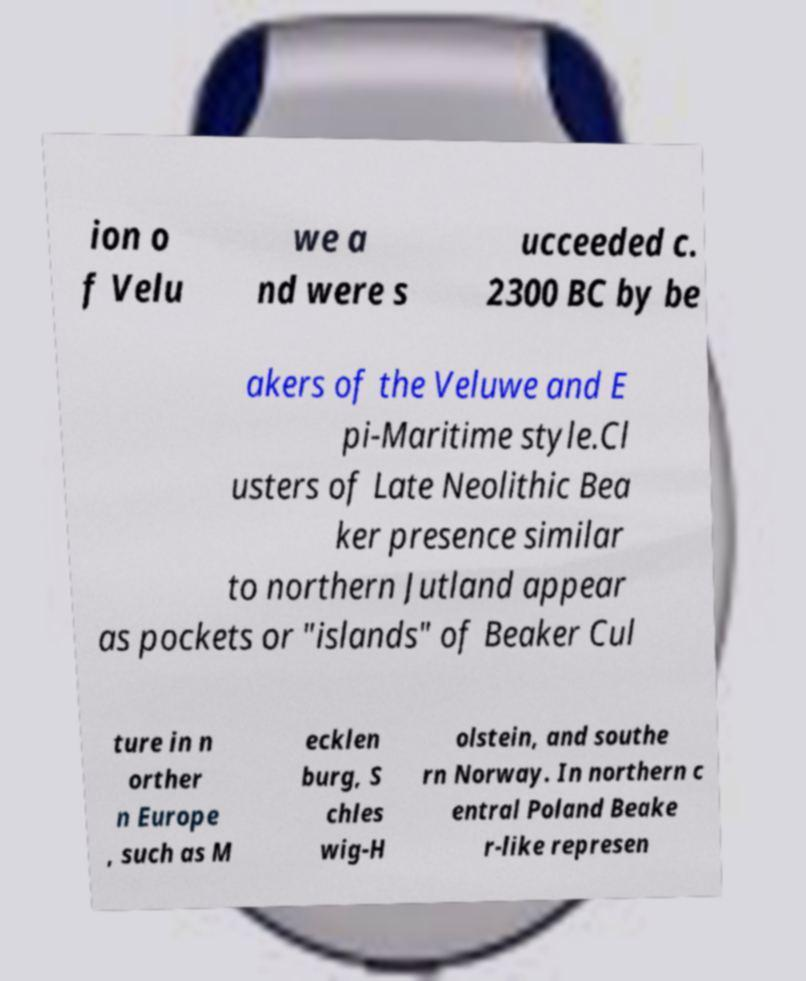Could you extract and type out the text from this image? ion o f Velu we a nd were s ucceeded c. 2300 BC by be akers of the Veluwe and E pi-Maritime style.Cl usters of Late Neolithic Bea ker presence similar to northern Jutland appear as pockets or "islands" of Beaker Cul ture in n orther n Europe , such as M ecklen burg, S chles wig-H olstein, and southe rn Norway. In northern c entral Poland Beake r-like represen 